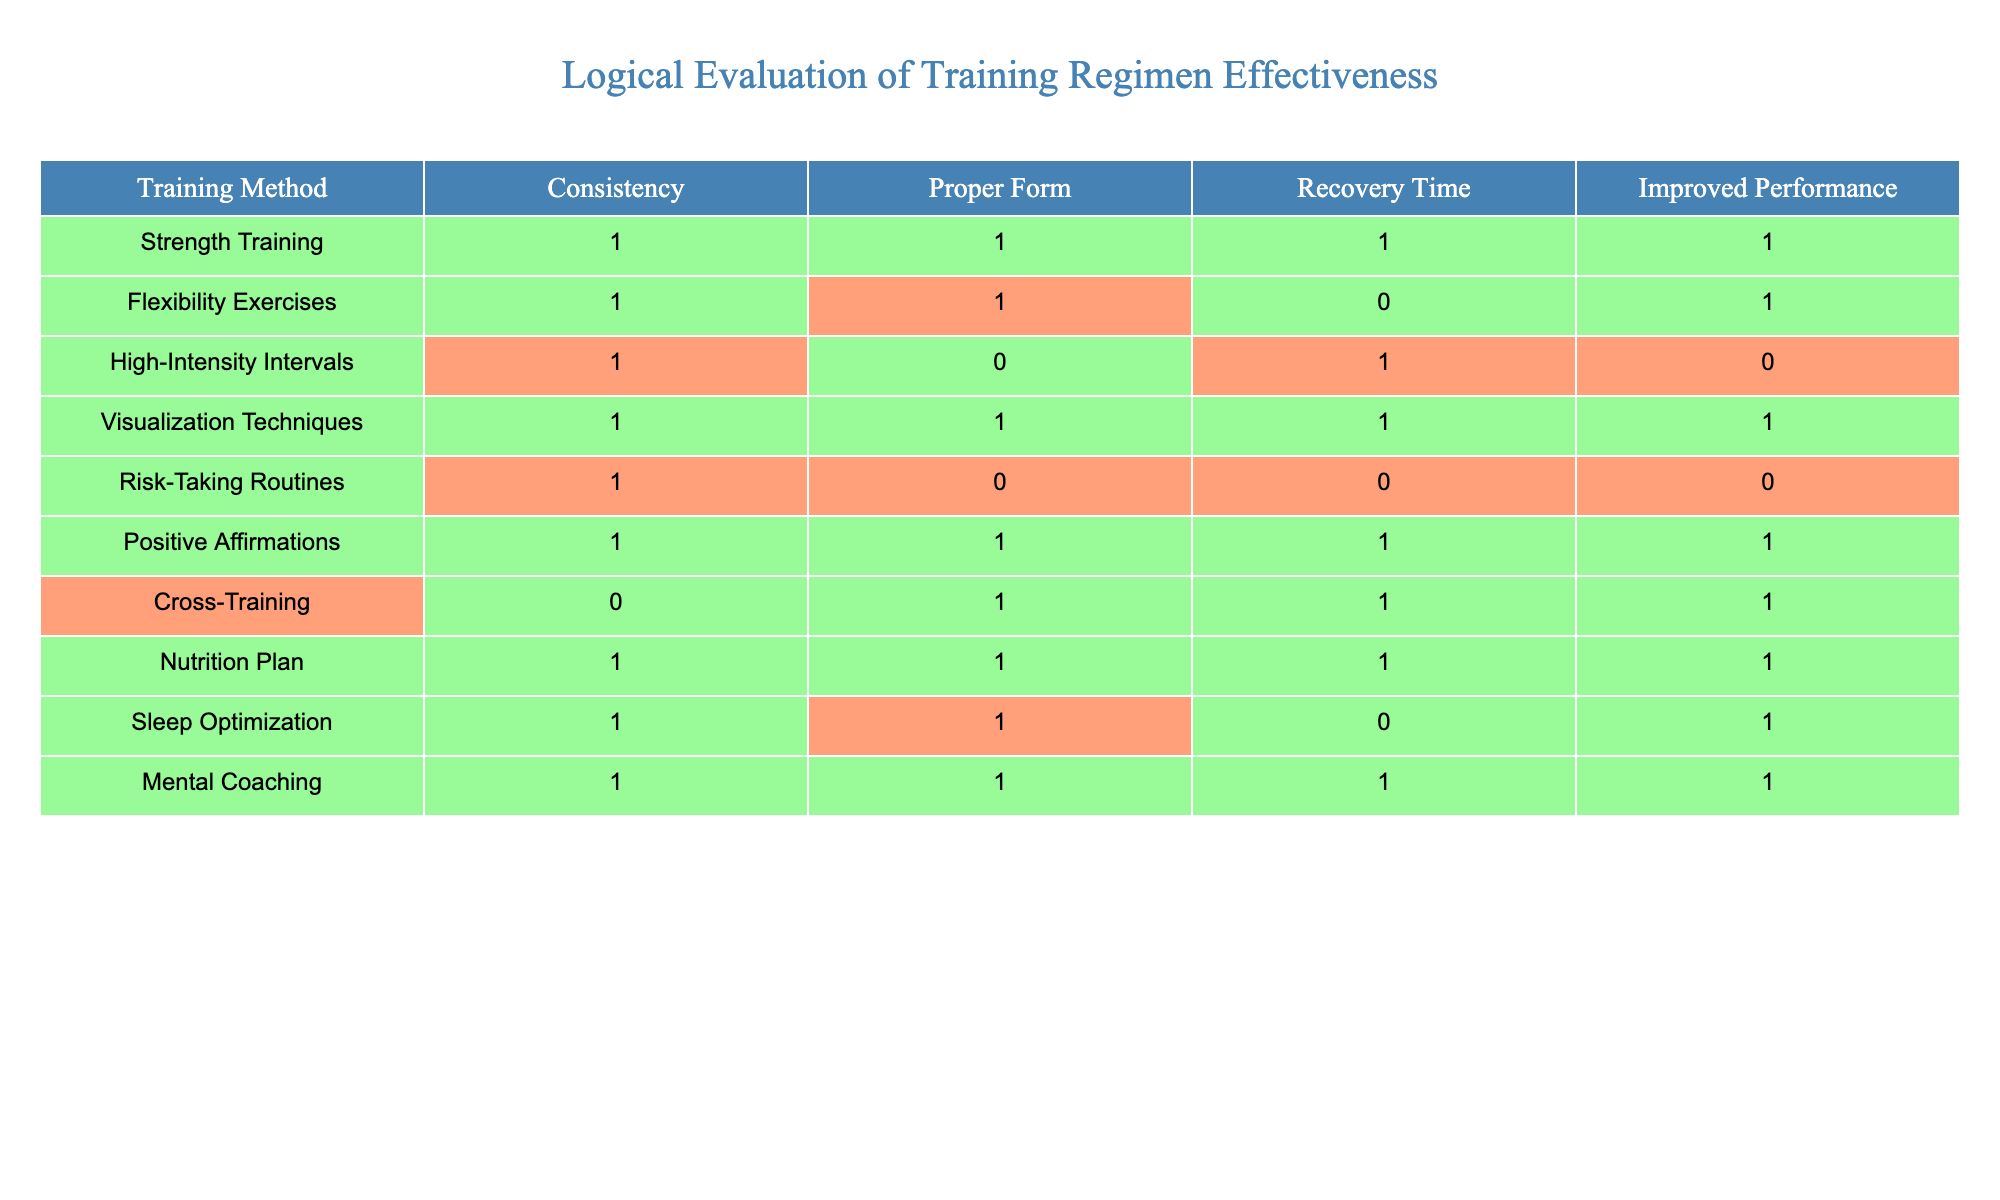What is the training method with the highest level of consistency? By examining the "Consistency" column, it shows that the "Strength Training", "Flexibility Exercises", "High-Intensity Intervals", "Visualization Techniques", "Risk-Taking Routines", "Positive Affirmations", "Nutrition Plan", "Sleep Optimization", and "Mental Coaching" have a value of 1. However, there are no training methods with a value other than 1. Hence, all of them are equally the highest in consistency.
Answer: Strength Training, Flexibility Exercises, High-Intensity Intervals, Visualization Techniques, Risk-Taking Routines, Positive Affirmations, Nutrition Plan, Sleep Optimization, Mental Coaching Which training method has both proper form and improved performance? To find this, we need to look at both the "Proper Form" and "Improved Performance" columns. The methods with a value of 1 in both columns are "Strength Training", "Flexibility Exercises", "Visualization Techniques", "Positive Affirmations", "Nutrition Plan", and "Mental Coaching".
Answer: Strength Training, Flexibility Exercises, Visualization Techniques, Positive Affirmations, Nutrition Plan, Mental Coaching How many training methods have a recovery time of 1? Looking at the "Recovery Time" column, we see that "Strength Training", "Flexibility Exercises", "High-Intensity Intervals", "Nutrition Plan", "Sleep Optimization", and "Mental Coaching" all have a value of 1. Counting these gives us a total of 5 training methods.
Answer: 5 Is High-Intensity Intervals effective in improving performance? To determine this, we check the "Improved Performance" column for "High-Intensity Intervals". It has a value of 0, which indicates that it is not effective in improving performance.
Answer: No Which training methods focus on positive mindset and risk-taking? We analyze the "Proper Form" and "Recovery Time" columns, where both "Risk-Taking Routines" (value of 0 for proper form and recovery) and "Positive Affirmations" (value of 1 for both) are present. However, "Risk-Taking Routines" does not fulfill the requirement for proper form. So, only "Positive Affirmations" serves this focus effectively.
Answer: Positive Affirmations What is the average performance improvement across the training methods? First, we look at the "Improved Performance" column and add the values: (1 + 1 + 0 + 1 + 0 + 1 + 1 + 1 + 0 + 1) = 7. There are 10 training methods, so the average is 7/10, which equals 0.7.
Answer: 0.7 Do all training methods with a value of 1 in consistency contribute to improved performance? We check if every training method marked with a 1 in the "Consistency" column also shows a 1 in the "Improved Performance" column. "High-Intensity Intervals" and "Risk-Taking Routines" have a 0 in improved performance, indicating that not all do.
Answer: No What training methods have low risk, indicated by both proper form and recovery time of 1? Reviewing the table, we note that "Strength Training", "Flexibility Exercises", "Visualization Techniques", "Positive Affirmations", "Nutrition Plan", and "Mental Coaching" all have 1 in both proper form and recovery. Therefore, these methods can be deemed low risk based on these attributes.
Answer: Strength Training, Flexibility Exercises, Visualization Techniques, Positive Affirmations, Nutrition Plan, Mental Coaching 